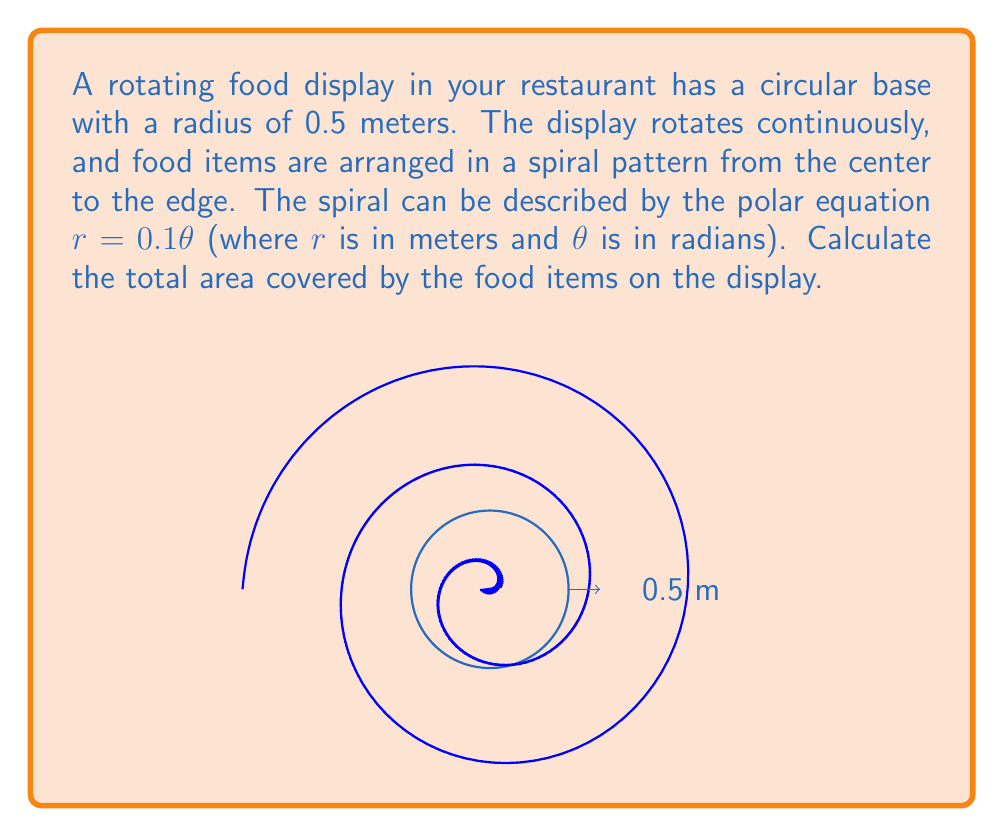Help me with this question. To solve this problem, we need to follow these steps:

1) The area of a region in polar coordinates is given by the formula:

   $$A = \frac{1}{2} \int_a^b [r(\theta)]^2 d\theta$$

2) In this case, $r(\theta) = 0.1\theta$, and we need to determine the limits of integration.

3) The spiral ends at the edge of the circular base, so we need to find the value of $\theta$ when $r = 0.5$ (the radius of the base):

   $$0.5 = 0.1\theta$$
   $$\theta = 5 \text{ radians}$$

4) So our limits of integration are from 0 to 5 radians.

5) Now we can set up our integral:

   $$A = \frac{1}{2} \int_0^5 (0.1\theta)^2 d\theta$$

6) Simplify the integrand:

   $$A = \frac{1}{2} \int_0^5 0.01\theta^2 d\theta$$

7) Integrate:

   $$A = \frac{1}{2} \cdot 0.01 \cdot [\frac{1}{3}\theta^3]_0^5$$

8) Evaluate the integral:

   $$A = 0.005 \cdot (\frac{1}{3} \cdot 125 - 0)$$
   $$A = 0.005 \cdot \frac{125}{3}$$
   $$A = \frac{0.625}{3} \approx 0.2083 \text{ square meters}$$
Answer: $$\frac{0.625}{3} \text{ m}^2$$ 